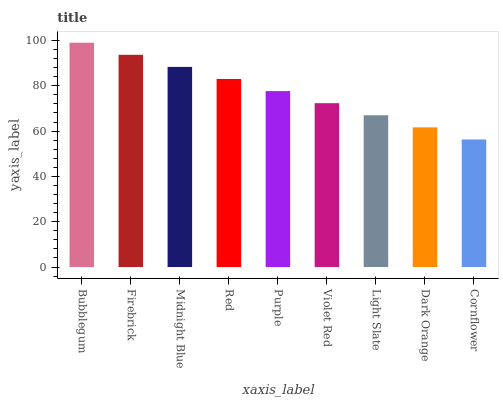Is Firebrick the minimum?
Answer yes or no. No. Is Firebrick the maximum?
Answer yes or no. No. Is Bubblegum greater than Firebrick?
Answer yes or no. Yes. Is Firebrick less than Bubblegum?
Answer yes or no. Yes. Is Firebrick greater than Bubblegum?
Answer yes or no. No. Is Bubblegum less than Firebrick?
Answer yes or no. No. Is Purple the high median?
Answer yes or no. Yes. Is Purple the low median?
Answer yes or no. Yes. Is Violet Red the high median?
Answer yes or no. No. Is Cornflower the low median?
Answer yes or no. No. 